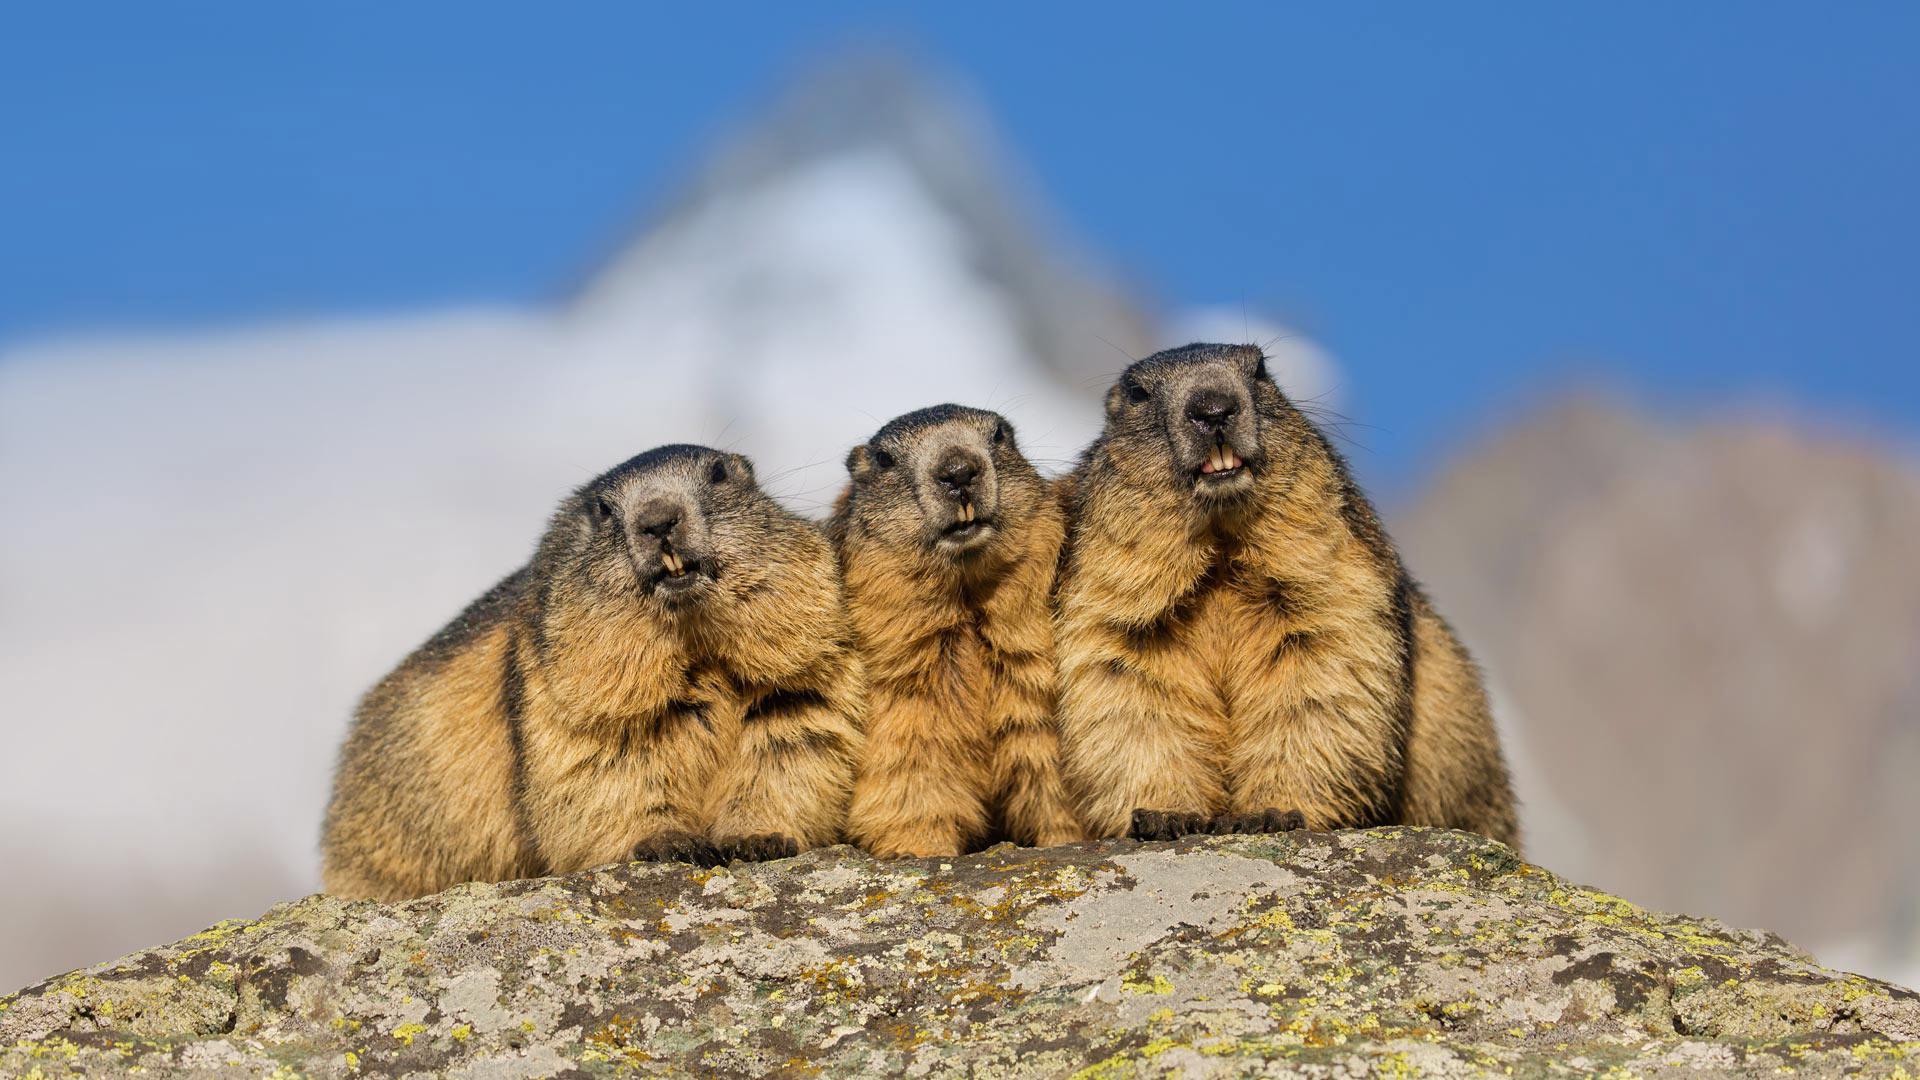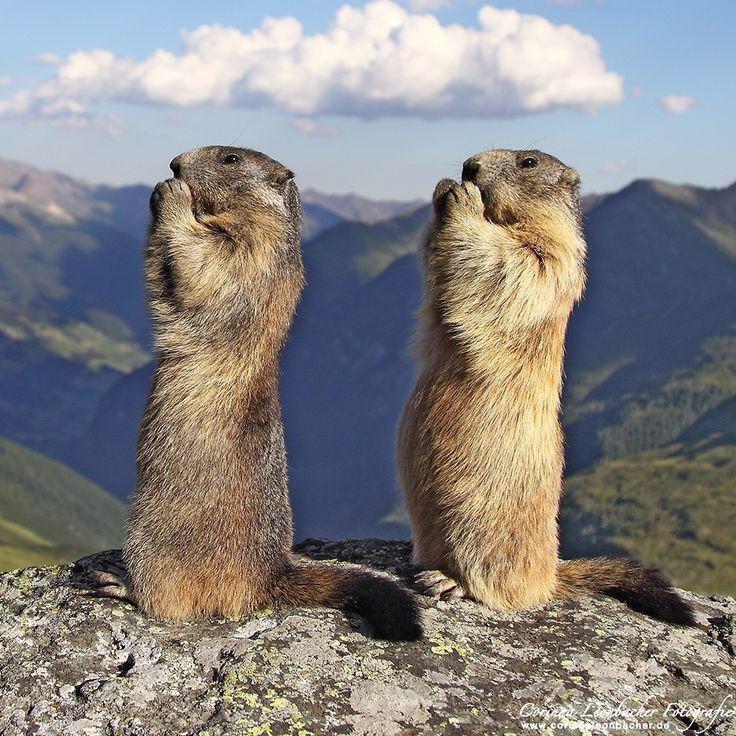The first image is the image on the left, the second image is the image on the right. Given the left and right images, does the statement "There are two marmots in the right image, and three on the left" hold true? Answer yes or no. Yes. 